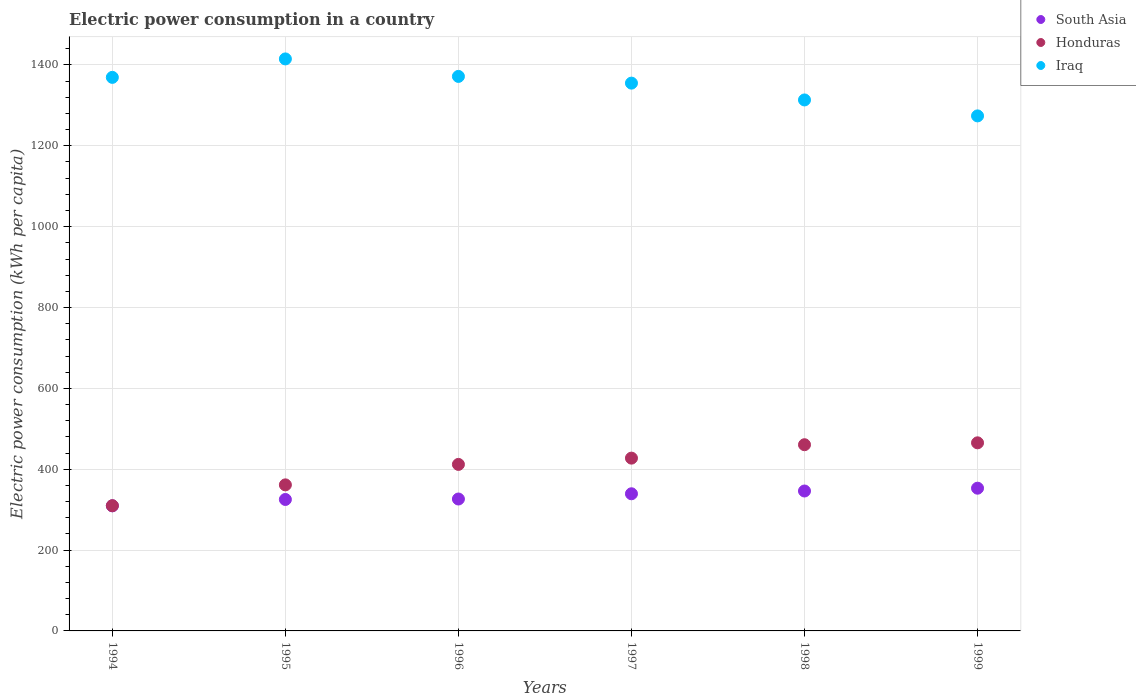How many different coloured dotlines are there?
Offer a very short reply. 3. Is the number of dotlines equal to the number of legend labels?
Make the answer very short. Yes. What is the electric power consumption in in Iraq in 1998?
Provide a short and direct response. 1313.46. Across all years, what is the maximum electric power consumption in in Iraq?
Ensure brevity in your answer.  1414.94. Across all years, what is the minimum electric power consumption in in South Asia?
Make the answer very short. 309.43. In which year was the electric power consumption in in South Asia maximum?
Make the answer very short. 1999. What is the total electric power consumption in in Honduras in the graph?
Keep it short and to the point. 2436.29. What is the difference between the electric power consumption in in Honduras in 1996 and that in 1998?
Offer a terse response. -48.69. What is the difference between the electric power consumption in in Iraq in 1995 and the electric power consumption in in South Asia in 1999?
Your response must be concise. 1061.88. What is the average electric power consumption in in Iraq per year?
Your answer should be very brief. 1349.74. In the year 1994, what is the difference between the electric power consumption in in Iraq and electric power consumption in in Honduras?
Give a very brief answer. 1059.53. In how many years, is the electric power consumption in in Iraq greater than 480 kWh per capita?
Your response must be concise. 6. What is the ratio of the electric power consumption in in Honduras in 1997 to that in 1999?
Your answer should be very brief. 0.92. Is the electric power consumption in in Iraq in 1994 less than that in 1995?
Your answer should be compact. Yes. Is the difference between the electric power consumption in in Iraq in 1994 and 1997 greater than the difference between the electric power consumption in in Honduras in 1994 and 1997?
Make the answer very short. Yes. What is the difference between the highest and the second highest electric power consumption in in Honduras?
Provide a succinct answer. 4.69. What is the difference between the highest and the lowest electric power consumption in in Iraq?
Your answer should be very brief. 140.95. In how many years, is the electric power consumption in in Iraq greater than the average electric power consumption in in Iraq taken over all years?
Your response must be concise. 4. Does the electric power consumption in in South Asia monotonically increase over the years?
Your response must be concise. Yes. Is the electric power consumption in in Honduras strictly less than the electric power consumption in in South Asia over the years?
Give a very brief answer. No. How many years are there in the graph?
Your response must be concise. 6. Are the values on the major ticks of Y-axis written in scientific E-notation?
Make the answer very short. No. Does the graph contain any zero values?
Provide a succinct answer. No. Does the graph contain grids?
Keep it short and to the point. Yes. Where does the legend appear in the graph?
Keep it short and to the point. Top right. How many legend labels are there?
Make the answer very short. 3. What is the title of the graph?
Provide a short and direct response. Electric power consumption in a country. What is the label or title of the Y-axis?
Your answer should be compact. Electric power consumption (kWh per capita). What is the Electric power consumption (kWh per capita) of South Asia in 1994?
Make the answer very short. 309.43. What is the Electric power consumption (kWh per capita) of Honduras in 1994?
Offer a very short reply. 309.78. What is the Electric power consumption (kWh per capita) in Iraq in 1994?
Make the answer very short. 1369.31. What is the Electric power consumption (kWh per capita) of South Asia in 1995?
Give a very brief answer. 325.17. What is the Electric power consumption (kWh per capita) in Honduras in 1995?
Your answer should be compact. 361.29. What is the Electric power consumption (kWh per capita) in Iraq in 1995?
Your answer should be very brief. 1414.94. What is the Electric power consumption (kWh per capita) of South Asia in 1996?
Offer a terse response. 326.29. What is the Electric power consumption (kWh per capita) in Honduras in 1996?
Your answer should be compact. 411.91. What is the Electric power consumption (kWh per capita) of Iraq in 1996?
Your response must be concise. 1371.68. What is the Electric power consumption (kWh per capita) in South Asia in 1997?
Give a very brief answer. 339.25. What is the Electric power consumption (kWh per capita) of Honduras in 1997?
Your answer should be compact. 427.43. What is the Electric power consumption (kWh per capita) of Iraq in 1997?
Provide a short and direct response. 1355.06. What is the Electric power consumption (kWh per capita) in South Asia in 1998?
Give a very brief answer. 346.11. What is the Electric power consumption (kWh per capita) in Honduras in 1998?
Keep it short and to the point. 460.6. What is the Electric power consumption (kWh per capita) in Iraq in 1998?
Ensure brevity in your answer.  1313.46. What is the Electric power consumption (kWh per capita) in South Asia in 1999?
Offer a terse response. 353.07. What is the Electric power consumption (kWh per capita) of Honduras in 1999?
Make the answer very short. 465.28. What is the Electric power consumption (kWh per capita) of Iraq in 1999?
Provide a succinct answer. 1274. Across all years, what is the maximum Electric power consumption (kWh per capita) of South Asia?
Your answer should be compact. 353.07. Across all years, what is the maximum Electric power consumption (kWh per capita) in Honduras?
Provide a short and direct response. 465.28. Across all years, what is the maximum Electric power consumption (kWh per capita) of Iraq?
Your answer should be very brief. 1414.94. Across all years, what is the minimum Electric power consumption (kWh per capita) in South Asia?
Give a very brief answer. 309.43. Across all years, what is the minimum Electric power consumption (kWh per capita) of Honduras?
Keep it short and to the point. 309.78. Across all years, what is the minimum Electric power consumption (kWh per capita) of Iraq?
Your answer should be compact. 1274. What is the total Electric power consumption (kWh per capita) in South Asia in the graph?
Provide a succinct answer. 1999.33. What is the total Electric power consumption (kWh per capita) of Honduras in the graph?
Provide a short and direct response. 2436.29. What is the total Electric power consumption (kWh per capita) of Iraq in the graph?
Ensure brevity in your answer.  8098.46. What is the difference between the Electric power consumption (kWh per capita) of South Asia in 1994 and that in 1995?
Your answer should be compact. -15.74. What is the difference between the Electric power consumption (kWh per capita) of Honduras in 1994 and that in 1995?
Ensure brevity in your answer.  -51.51. What is the difference between the Electric power consumption (kWh per capita) of Iraq in 1994 and that in 1995?
Offer a very short reply. -45.63. What is the difference between the Electric power consumption (kWh per capita) in South Asia in 1994 and that in 1996?
Provide a short and direct response. -16.86. What is the difference between the Electric power consumption (kWh per capita) in Honduras in 1994 and that in 1996?
Offer a terse response. -102.13. What is the difference between the Electric power consumption (kWh per capita) in Iraq in 1994 and that in 1996?
Your answer should be very brief. -2.37. What is the difference between the Electric power consumption (kWh per capita) in South Asia in 1994 and that in 1997?
Offer a very short reply. -29.82. What is the difference between the Electric power consumption (kWh per capita) in Honduras in 1994 and that in 1997?
Your answer should be compact. -117.65. What is the difference between the Electric power consumption (kWh per capita) in Iraq in 1994 and that in 1997?
Offer a very short reply. 14.26. What is the difference between the Electric power consumption (kWh per capita) in South Asia in 1994 and that in 1998?
Offer a terse response. -36.68. What is the difference between the Electric power consumption (kWh per capita) in Honduras in 1994 and that in 1998?
Your response must be concise. -150.82. What is the difference between the Electric power consumption (kWh per capita) in Iraq in 1994 and that in 1998?
Keep it short and to the point. 55.85. What is the difference between the Electric power consumption (kWh per capita) of South Asia in 1994 and that in 1999?
Your response must be concise. -43.64. What is the difference between the Electric power consumption (kWh per capita) in Honduras in 1994 and that in 1999?
Keep it short and to the point. -155.5. What is the difference between the Electric power consumption (kWh per capita) in Iraq in 1994 and that in 1999?
Keep it short and to the point. 95.32. What is the difference between the Electric power consumption (kWh per capita) in South Asia in 1995 and that in 1996?
Keep it short and to the point. -1.12. What is the difference between the Electric power consumption (kWh per capita) of Honduras in 1995 and that in 1996?
Your response must be concise. -50.62. What is the difference between the Electric power consumption (kWh per capita) in Iraq in 1995 and that in 1996?
Your response must be concise. 43.26. What is the difference between the Electric power consumption (kWh per capita) in South Asia in 1995 and that in 1997?
Your response must be concise. -14.08. What is the difference between the Electric power consumption (kWh per capita) in Honduras in 1995 and that in 1997?
Your answer should be very brief. -66.14. What is the difference between the Electric power consumption (kWh per capita) of Iraq in 1995 and that in 1997?
Offer a very short reply. 59.88. What is the difference between the Electric power consumption (kWh per capita) in South Asia in 1995 and that in 1998?
Offer a very short reply. -20.94. What is the difference between the Electric power consumption (kWh per capita) of Honduras in 1995 and that in 1998?
Offer a very short reply. -99.31. What is the difference between the Electric power consumption (kWh per capita) in Iraq in 1995 and that in 1998?
Your response must be concise. 101.48. What is the difference between the Electric power consumption (kWh per capita) of South Asia in 1995 and that in 1999?
Ensure brevity in your answer.  -27.9. What is the difference between the Electric power consumption (kWh per capita) in Honduras in 1995 and that in 1999?
Offer a terse response. -104. What is the difference between the Electric power consumption (kWh per capita) in Iraq in 1995 and that in 1999?
Give a very brief answer. 140.95. What is the difference between the Electric power consumption (kWh per capita) in South Asia in 1996 and that in 1997?
Provide a succinct answer. -12.96. What is the difference between the Electric power consumption (kWh per capita) in Honduras in 1996 and that in 1997?
Keep it short and to the point. -15.52. What is the difference between the Electric power consumption (kWh per capita) of Iraq in 1996 and that in 1997?
Offer a terse response. 16.62. What is the difference between the Electric power consumption (kWh per capita) of South Asia in 1996 and that in 1998?
Provide a short and direct response. -19.82. What is the difference between the Electric power consumption (kWh per capita) of Honduras in 1996 and that in 1998?
Your answer should be very brief. -48.69. What is the difference between the Electric power consumption (kWh per capita) in Iraq in 1996 and that in 1998?
Provide a succinct answer. 58.22. What is the difference between the Electric power consumption (kWh per capita) of South Asia in 1996 and that in 1999?
Your response must be concise. -26.77. What is the difference between the Electric power consumption (kWh per capita) of Honduras in 1996 and that in 1999?
Offer a terse response. -53.38. What is the difference between the Electric power consumption (kWh per capita) in Iraq in 1996 and that in 1999?
Give a very brief answer. 97.69. What is the difference between the Electric power consumption (kWh per capita) of South Asia in 1997 and that in 1998?
Your answer should be very brief. -6.86. What is the difference between the Electric power consumption (kWh per capita) of Honduras in 1997 and that in 1998?
Your response must be concise. -33.17. What is the difference between the Electric power consumption (kWh per capita) in Iraq in 1997 and that in 1998?
Your answer should be compact. 41.59. What is the difference between the Electric power consumption (kWh per capita) of South Asia in 1997 and that in 1999?
Your answer should be compact. -13.82. What is the difference between the Electric power consumption (kWh per capita) of Honduras in 1997 and that in 1999?
Offer a terse response. -37.86. What is the difference between the Electric power consumption (kWh per capita) of Iraq in 1997 and that in 1999?
Your answer should be compact. 81.06. What is the difference between the Electric power consumption (kWh per capita) of South Asia in 1998 and that in 1999?
Your response must be concise. -6.95. What is the difference between the Electric power consumption (kWh per capita) in Honduras in 1998 and that in 1999?
Your answer should be very brief. -4.69. What is the difference between the Electric power consumption (kWh per capita) in Iraq in 1998 and that in 1999?
Make the answer very short. 39.47. What is the difference between the Electric power consumption (kWh per capita) in South Asia in 1994 and the Electric power consumption (kWh per capita) in Honduras in 1995?
Your answer should be very brief. -51.85. What is the difference between the Electric power consumption (kWh per capita) in South Asia in 1994 and the Electric power consumption (kWh per capita) in Iraq in 1995?
Make the answer very short. -1105.51. What is the difference between the Electric power consumption (kWh per capita) of Honduras in 1994 and the Electric power consumption (kWh per capita) of Iraq in 1995?
Ensure brevity in your answer.  -1105.16. What is the difference between the Electric power consumption (kWh per capita) in South Asia in 1994 and the Electric power consumption (kWh per capita) in Honduras in 1996?
Ensure brevity in your answer.  -102.48. What is the difference between the Electric power consumption (kWh per capita) of South Asia in 1994 and the Electric power consumption (kWh per capita) of Iraq in 1996?
Your response must be concise. -1062.25. What is the difference between the Electric power consumption (kWh per capita) in Honduras in 1994 and the Electric power consumption (kWh per capita) in Iraq in 1996?
Provide a short and direct response. -1061.9. What is the difference between the Electric power consumption (kWh per capita) of South Asia in 1994 and the Electric power consumption (kWh per capita) of Honduras in 1997?
Give a very brief answer. -118. What is the difference between the Electric power consumption (kWh per capita) of South Asia in 1994 and the Electric power consumption (kWh per capita) of Iraq in 1997?
Offer a very short reply. -1045.63. What is the difference between the Electric power consumption (kWh per capita) of Honduras in 1994 and the Electric power consumption (kWh per capita) of Iraq in 1997?
Your answer should be compact. -1045.28. What is the difference between the Electric power consumption (kWh per capita) in South Asia in 1994 and the Electric power consumption (kWh per capita) in Honduras in 1998?
Make the answer very short. -151.17. What is the difference between the Electric power consumption (kWh per capita) of South Asia in 1994 and the Electric power consumption (kWh per capita) of Iraq in 1998?
Offer a very short reply. -1004.03. What is the difference between the Electric power consumption (kWh per capita) of Honduras in 1994 and the Electric power consumption (kWh per capita) of Iraq in 1998?
Give a very brief answer. -1003.68. What is the difference between the Electric power consumption (kWh per capita) in South Asia in 1994 and the Electric power consumption (kWh per capita) in Honduras in 1999?
Make the answer very short. -155.85. What is the difference between the Electric power consumption (kWh per capita) of South Asia in 1994 and the Electric power consumption (kWh per capita) of Iraq in 1999?
Keep it short and to the point. -964.56. What is the difference between the Electric power consumption (kWh per capita) in Honduras in 1994 and the Electric power consumption (kWh per capita) in Iraq in 1999?
Keep it short and to the point. -964.22. What is the difference between the Electric power consumption (kWh per capita) in South Asia in 1995 and the Electric power consumption (kWh per capita) in Honduras in 1996?
Your answer should be very brief. -86.74. What is the difference between the Electric power consumption (kWh per capita) of South Asia in 1995 and the Electric power consumption (kWh per capita) of Iraq in 1996?
Give a very brief answer. -1046.51. What is the difference between the Electric power consumption (kWh per capita) of Honduras in 1995 and the Electric power consumption (kWh per capita) of Iraq in 1996?
Make the answer very short. -1010.4. What is the difference between the Electric power consumption (kWh per capita) of South Asia in 1995 and the Electric power consumption (kWh per capita) of Honduras in 1997?
Provide a short and direct response. -102.26. What is the difference between the Electric power consumption (kWh per capita) in South Asia in 1995 and the Electric power consumption (kWh per capita) in Iraq in 1997?
Provide a succinct answer. -1029.89. What is the difference between the Electric power consumption (kWh per capita) of Honduras in 1995 and the Electric power consumption (kWh per capita) of Iraq in 1997?
Ensure brevity in your answer.  -993.77. What is the difference between the Electric power consumption (kWh per capita) of South Asia in 1995 and the Electric power consumption (kWh per capita) of Honduras in 1998?
Ensure brevity in your answer.  -135.43. What is the difference between the Electric power consumption (kWh per capita) of South Asia in 1995 and the Electric power consumption (kWh per capita) of Iraq in 1998?
Keep it short and to the point. -988.29. What is the difference between the Electric power consumption (kWh per capita) in Honduras in 1995 and the Electric power consumption (kWh per capita) in Iraq in 1998?
Make the answer very short. -952.18. What is the difference between the Electric power consumption (kWh per capita) of South Asia in 1995 and the Electric power consumption (kWh per capita) of Honduras in 1999?
Provide a succinct answer. -140.12. What is the difference between the Electric power consumption (kWh per capita) in South Asia in 1995 and the Electric power consumption (kWh per capita) in Iraq in 1999?
Give a very brief answer. -948.83. What is the difference between the Electric power consumption (kWh per capita) in Honduras in 1995 and the Electric power consumption (kWh per capita) in Iraq in 1999?
Provide a short and direct response. -912.71. What is the difference between the Electric power consumption (kWh per capita) of South Asia in 1996 and the Electric power consumption (kWh per capita) of Honduras in 1997?
Your response must be concise. -101.13. What is the difference between the Electric power consumption (kWh per capita) of South Asia in 1996 and the Electric power consumption (kWh per capita) of Iraq in 1997?
Offer a terse response. -1028.77. What is the difference between the Electric power consumption (kWh per capita) in Honduras in 1996 and the Electric power consumption (kWh per capita) in Iraq in 1997?
Make the answer very short. -943.15. What is the difference between the Electric power consumption (kWh per capita) of South Asia in 1996 and the Electric power consumption (kWh per capita) of Honduras in 1998?
Offer a very short reply. -134.31. What is the difference between the Electric power consumption (kWh per capita) in South Asia in 1996 and the Electric power consumption (kWh per capita) in Iraq in 1998?
Ensure brevity in your answer.  -987.17. What is the difference between the Electric power consumption (kWh per capita) of Honduras in 1996 and the Electric power consumption (kWh per capita) of Iraq in 1998?
Keep it short and to the point. -901.56. What is the difference between the Electric power consumption (kWh per capita) in South Asia in 1996 and the Electric power consumption (kWh per capita) in Honduras in 1999?
Provide a short and direct response. -138.99. What is the difference between the Electric power consumption (kWh per capita) of South Asia in 1996 and the Electric power consumption (kWh per capita) of Iraq in 1999?
Your response must be concise. -947.7. What is the difference between the Electric power consumption (kWh per capita) in Honduras in 1996 and the Electric power consumption (kWh per capita) in Iraq in 1999?
Provide a short and direct response. -862.09. What is the difference between the Electric power consumption (kWh per capita) of South Asia in 1997 and the Electric power consumption (kWh per capita) of Honduras in 1998?
Give a very brief answer. -121.35. What is the difference between the Electric power consumption (kWh per capita) of South Asia in 1997 and the Electric power consumption (kWh per capita) of Iraq in 1998?
Your answer should be very brief. -974.21. What is the difference between the Electric power consumption (kWh per capita) in Honduras in 1997 and the Electric power consumption (kWh per capita) in Iraq in 1998?
Keep it short and to the point. -886.04. What is the difference between the Electric power consumption (kWh per capita) of South Asia in 1997 and the Electric power consumption (kWh per capita) of Honduras in 1999?
Your response must be concise. -126.04. What is the difference between the Electric power consumption (kWh per capita) of South Asia in 1997 and the Electric power consumption (kWh per capita) of Iraq in 1999?
Your answer should be very brief. -934.75. What is the difference between the Electric power consumption (kWh per capita) of Honduras in 1997 and the Electric power consumption (kWh per capita) of Iraq in 1999?
Provide a short and direct response. -846.57. What is the difference between the Electric power consumption (kWh per capita) of South Asia in 1998 and the Electric power consumption (kWh per capita) of Honduras in 1999?
Offer a terse response. -119.17. What is the difference between the Electric power consumption (kWh per capita) of South Asia in 1998 and the Electric power consumption (kWh per capita) of Iraq in 1999?
Offer a terse response. -927.88. What is the difference between the Electric power consumption (kWh per capita) in Honduras in 1998 and the Electric power consumption (kWh per capita) in Iraq in 1999?
Provide a short and direct response. -813.4. What is the average Electric power consumption (kWh per capita) in South Asia per year?
Provide a succinct answer. 333.22. What is the average Electric power consumption (kWh per capita) of Honduras per year?
Provide a short and direct response. 406.05. What is the average Electric power consumption (kWh per capita) of Iraq per year?
Offer a very short reply. 1349.74. In the year 1994, what is the difference between the Electric power consumption (kWh per capita) in South Asia and Electric power consumption (kWh per capita) in Honduras?
Ensure brevity in your answer.  -0.35. In the year 1994, what is the difference between the Electric power consumption (kWh per capita) of South Asia and Electric power consumption (kWh per capita) of Iraq?
Ensure brevity in your answer.  -1059.88. In the year 1994, what is the difference between the Electric power consumption (kWh per capita) in Honduras and Electric power consumption (kWh per capita) in Iraq?
Give a very brief answer. -1059.53. In the year 1995, what is the difference between the Electric power consumption (kWh per capita) in South Asia and Electric power consumption (kWh per capita) in Honduras?
Give a very brief answer. -36.12. In the year 1995, what is the difference between the Electric power consumption (kWh per capita) of South Asia and Electric power consumption (kWh per capita) of Iraq?
Provide a succinct answer. -1089.77. In the year 1995, what is the difference between the Electric power consumption (kWh per capita) of Honduras and Electric power consumption (kWh per capita) of Iraq?
Provide a succinct answer. -1053.66. In the year 1996, what is the difference between the Electric power consumption (kWh per capita) of South Asia and Electric power consumption (kWh per capita) of Honduras?
Offer a very short reply. -85.61. In the year 1996, what is the difference between the Electric power consumption (kWh per capita) in South Asia and Electric power consumption (kWh per capita) in Iraq?
Make the answer very short. -1045.39. In the year 1996, what is the difference between the Electric power consumption (kWh per capita) of Honduras and Electric power consumption (kWh per capita) of Iraq?
Give a very brief answer. -959.78. In the year 1997, what is the difference between the Electric power consumption (kWh per capita) in South Asia and Electric power consumption (kWh per capita) in Honduras?
Make the answer very short. -88.18. In the year 1997, what is the difference between the Electric power consumption (kWh per capita) of South Asia and Electric power consumption (kWh per capita) of Iraq?
Your answer should be compact. -1015.81. In the year 1997, what is the difference between the Electric power consumption (kWh per capita) of Honduras and Electric power consumption (kWh per capita) of Iraq?
Offer a terse response. -927.63. In the year 1998, what is the difference between the Electric power consumption (kWh per capita) in South Asia and Electric power consumption (kWh per capita) in Honduras?
Your response must be concise. -114.49. In the year 1998, what is the difference between the Electric power consumption (kWh per capita) of South Asia and Electric power consumption (kWh per capita) of Iraq?
Offer a very short reply. -967.35. In the year 1998, what is the difference between the Electric power consumption (kWh per capita) of Honduras and Electric power consumption (kWh per capita) of Iraq?
Offer a very short reply. -852.86. In the year 1999, what is the difference between the Electric power consumption (kWh per capita) in South Asia and Electric power consumption (kWh per capita) in Honduras?
Provide a succinct answer. -112.22. In the year 1999, what is the difference between the Electric power consumption (kWh per capita) in South Asia and Electric power consumption (kWh per capita) in Iraq?
Offer a very short reply. -920.93. In the year 1999, what is the difference between the Electric power consumption (kWh per capita) of Honduras and Electric power consumption (kWh per capita) of Iraq?
Keep it short and to the point. -808.71. What is the ratio of the Electric power consumption (kWh per capita) of South Asia in 1994 to that in 1995?
Ensure brevity in your answer.  0.95. What is the ratio of the Electric power consumption (kWh per capita) of Honduras in 1994 to that in 1995?
Your answer should be compact. 0.86. What is the ratio of the Electric power consumption (kWh per capita) of Iraq in 1994 to that in 1995?
Give a very brief answer. 0.97. What is the ratio of the Electric power consumption (kWh per capita) in South Asia in 1994 to that in 1996?
Ensure brevity in your answer.  0.95. What is the ratio of the Electric power consumption (kWh per capita) of Honduras in 1994 to that in 1996?
Ensure brevity in your answer.  0.75. What is the ratio of the Electric power consumption (kWh per capita) of Iraq in 1994 to that in 1996?
Your response must be concise. 1. What is the ratio of the Electric power consumption (kWh per capita) of South Asia in 1994 to that in 1997?
Ensure brevity in your answer.  0.91. What is the ratio of the Electric power consumption (kWh per capita) of Honduras in 1994 to that in 1997?
Offer a terse response. 0.72. What is the ratio of the Electric power consumption (kWh per capita) of Iraq in 1994 to that in 1997?
Offer a very short reply. 1.01. What is the ratio of the Electric power consumption (kWh per capita) of South Asia in 1994 to that in 1998?
Make the answer very short. 0.89. What is the ratio of the Electric power consumption (kWh per capita) in Honduras in 1994 to that in 1998?
Make the answer very short. 0.67. What is the ratio of the Electric power consumption (kWh per capita) of Iraq in 1994 to that in 1998?
Make the answer very short. 1.04. What is the ratio of the Electric power consumption (kWh per capita) in South Asia in 1994 to that in 1999?
Offer a very short reply. 0.88. What is the ratio of the Electric power consumption (kWh per capita) in Honduras in 1994 to that in 1999?
Your response must be concise. 0.67. What is the ratio of the Electric power consumption (kWh per capita) in Iraq in 1994 to that in 1999?
Offer a very short reply. 1.07. What is the ratio of the Electric power consumption (kWh per capita) of South Asia in 1995 to that in 1996?
Ensure brevity in your answer.  1. What is the ratio of the Electric power consumption (kWh per capita) of Honduras in 1995 to that in 1996?
Your answer should be compact. 0.88. What is the ratio of the Electric power consumption (kWh per capita) in Iraq in 1995 to that in 1996?
Keep it short and to the point. 1.03. What is the ratio of the Electric power consumption (kWh per capita) of South Asia in 1995 to that in 1997?
Provide a succinct answer. 0.96. What is the ratio of the Electric power consumption (kWh per capita) in Honduras in 1995 to that in 1997?
Keep it short and to the point. 0.85. What is the ratio of the Electric power consumption (kWh per capita) in Iraq in 1995 to that in 1997?
Your answer should be compact. 1.04. What is the ratio of the Electric power consumption (kWh per capita) of South Asia in 1995 to that in 1998?
Your answer should be compact. 0.94. What is the ratio of the Electric power consumption (kWh per capita) of Honduras in 1995 to that in 1998?
Provide a short and direct response. 0.78. What is the ratio of the Electric power consumption (kWh per capita) of Iraq in 1995 to that in 1998?
Ensure brevity in your answer.  1.08. What is the ratio of the Electric power consumption (kWh per capita) of South Asia in 1995 to that in 1999?
Ensure brevity in your answer.  0.92. What is the ratio of the Electric power consumption (kWh per capita) in Honduras in 1995 to that in 1999?
Provide a succinct answer. 0.78. What is the ratio of the Electric power consumption (kWh per capita) in Iraq in 1995 to that in 1999?
Provide a succinct answer. 1.11. What is the ratio of the Electric power consumption (kWh per capita) of South Asia in 1996 to that in 1997?
Make the answer very short. 0.96. What is the ratio of the Electric power consumption (kWh per capita) in Honduras in 1996 to that in 1997?
Offer a terse response. 0.96. What is the ratio of the Electric power consumption (kWh per capita) of Iraq in 1996 to that in 1997?
Ensure brevity in your answer.  1.01. What is the ratio of the Electric power consumption (kWh per capita) in South Asia in 1996 to that in 1998?
Your response must be concise. 0.94. What is the ratio of the Electric power consumption (kWh per capita) in Honduras in 1996 to that in 1998?
Ensure brevity in your answer.  0.89. What is the ratio of the Electric power consumption (kWh per capita) in Iraq in 1996 to that in 1998?
Give a very brief answer. 1.04. What is the ratio of the Electric power consumption (kWh per capita) in South Asia in 1996 to that in 1999?
Your answer should be compact. 0.92. What is the ratio of the Electric power consumption (kWh per capita) in Honduras in 1996 to that in 1999?
Make the answer very short. 0.89. What is the ratio of the Electric power consumption (kWh per capita) in Iraq in 1996 to that in 1999?
Ensure brevity in your answer.  1.08. What is the ratio of the Electric power consumption (kWh per capita) of South Asia in 1997 to that in 1998?
Your answer should be compact. 0.98. What is the ratio of the Electric power consumption (kWh per capita) of Honduras in 1997 to that in 1998?
Offer a terse response. 0.93. What is the ratio of the Electric power consumption (kWh per capita) in Iraq in 1997 to that in 1998?
Your answer should be compact. 1.03. What is the ratio of the Electric power consumption (kWh per capita) of South Asia in 1997 to that in 1999?
Offer a very short reply. 0.96. What is the ratio of the Electric power consumption (kWh per capita) of Honduras in 1997 to that in 1999?
Provide a succinct answer. 0.92. What is the ratio of the Electric power consumption (kWh per capita) in Iraq in 1997 to that in 1999?
Ensure brevity in your answer.  1.06. What is the ratio of the Electric power consumption (kWh per capita) of South Asia in 1998 to that in 1999?
Keep it short and to the point. 0.98. What is the ratio of the Electric power consumption (kWh per capita) in Iraq in 1998 to that in 1999?
Your answer should be very brief. 1.03. What is the difference between the highest and the second highest Electric power consumption (kWh per capita) in South Asia?
Offer a terse response. 6.95. What is the difference between the highest and the second highest Electric power consumption (kWh per capita) in Honduras?
Offer a very short reply. 4.69. What is the difference between the highest and the second highest Electric power consumption (kWh per capita) of Iraq?
Your response must be concise. 43.26. What is the difference between the highest and the lowest Electric power consumption (kWh per capita) of South Asia?
Your answer should be very brief. 43.64. What is the difference between the highest and the lowest Electric power consumption (kWh per capita) in Honduras?
Make the answer very short. 155.5. What is the difference between the highest and the lowest Electric power consumption (kWh per capita) of Iraq?
Give a very brief answer. 140.95. 